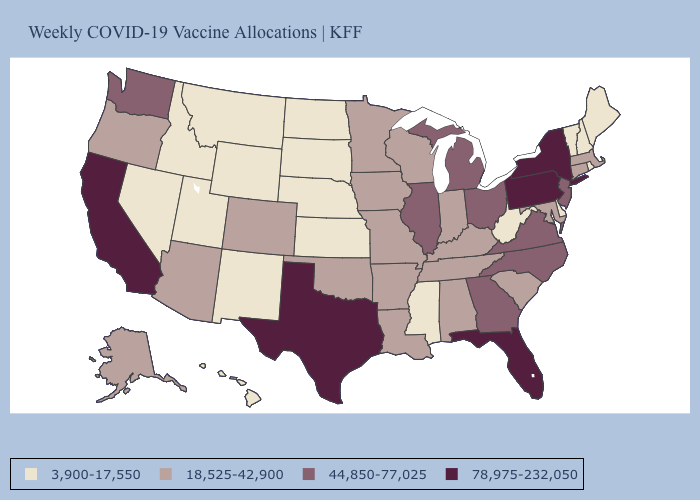Among the states that border Nevada , does Oregon have the lowest value?
Write a very short answer. No. Among the states that border Arizona , does California have the highest value?
Keep it brief. Yes. Among the states that border Virginia , does North Carolina have the highest value?
Short answer required. Yes. Does Washington have the lowest value in the USA?
Give a very brief answer. No. Name the states that have a value in the range 3,900-17,550?
Give a very brief answer. Delaware, Hawaii, Idaho, Kansas, Maine, Mississippi, Montana, Nebraska, Nevada, New Hampshire, New Mexico, North Dakota, Rhode Island, South Dakota, Utah, Vermont, West Virginia, Wyoming. What is the value of Maine?
Give a very brief answer. 3,900-17,550. Name the states that have a value in the range 44,850-77,025?
Give a very brief answer. Georgia, Illinois, Michigan, New Jersey, North Carolina, Ohio, Virginia, Washington. What is the highest value in states that border New Jersey?
Concise answer only. 78,975-232,050. What is the value of Vermont?
Keep it brief. 3,900-17,550. What is the value of Rhode Island?
Give a very brief answer. 3,900-17,550. Name the states that have a value in the range 3,900-17,550?
Write a very short answer. Delaware, Hawaii, Idaho, Kansas, Maine, Mississippi, Montana, Nebraska, Nevada, New Hampshire, New Mexico, North Dakota, Rhode Island, South Dakota, Utah, Vermont, West Virginia, Wyoming. What is the value of Maryland?
Quick response, please. 18,525-42,900. Does Louisiana have the lowest value in the South?
Quick response, please. No. What is the highest value in the USA?
Write a very short answer. 78,975-232,050. How many symbols are there in the legend?
Be succinct. 4. 